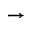<formula> <loc_0><loc_0><loc_500><loc_500>\rightarrow</formula> 